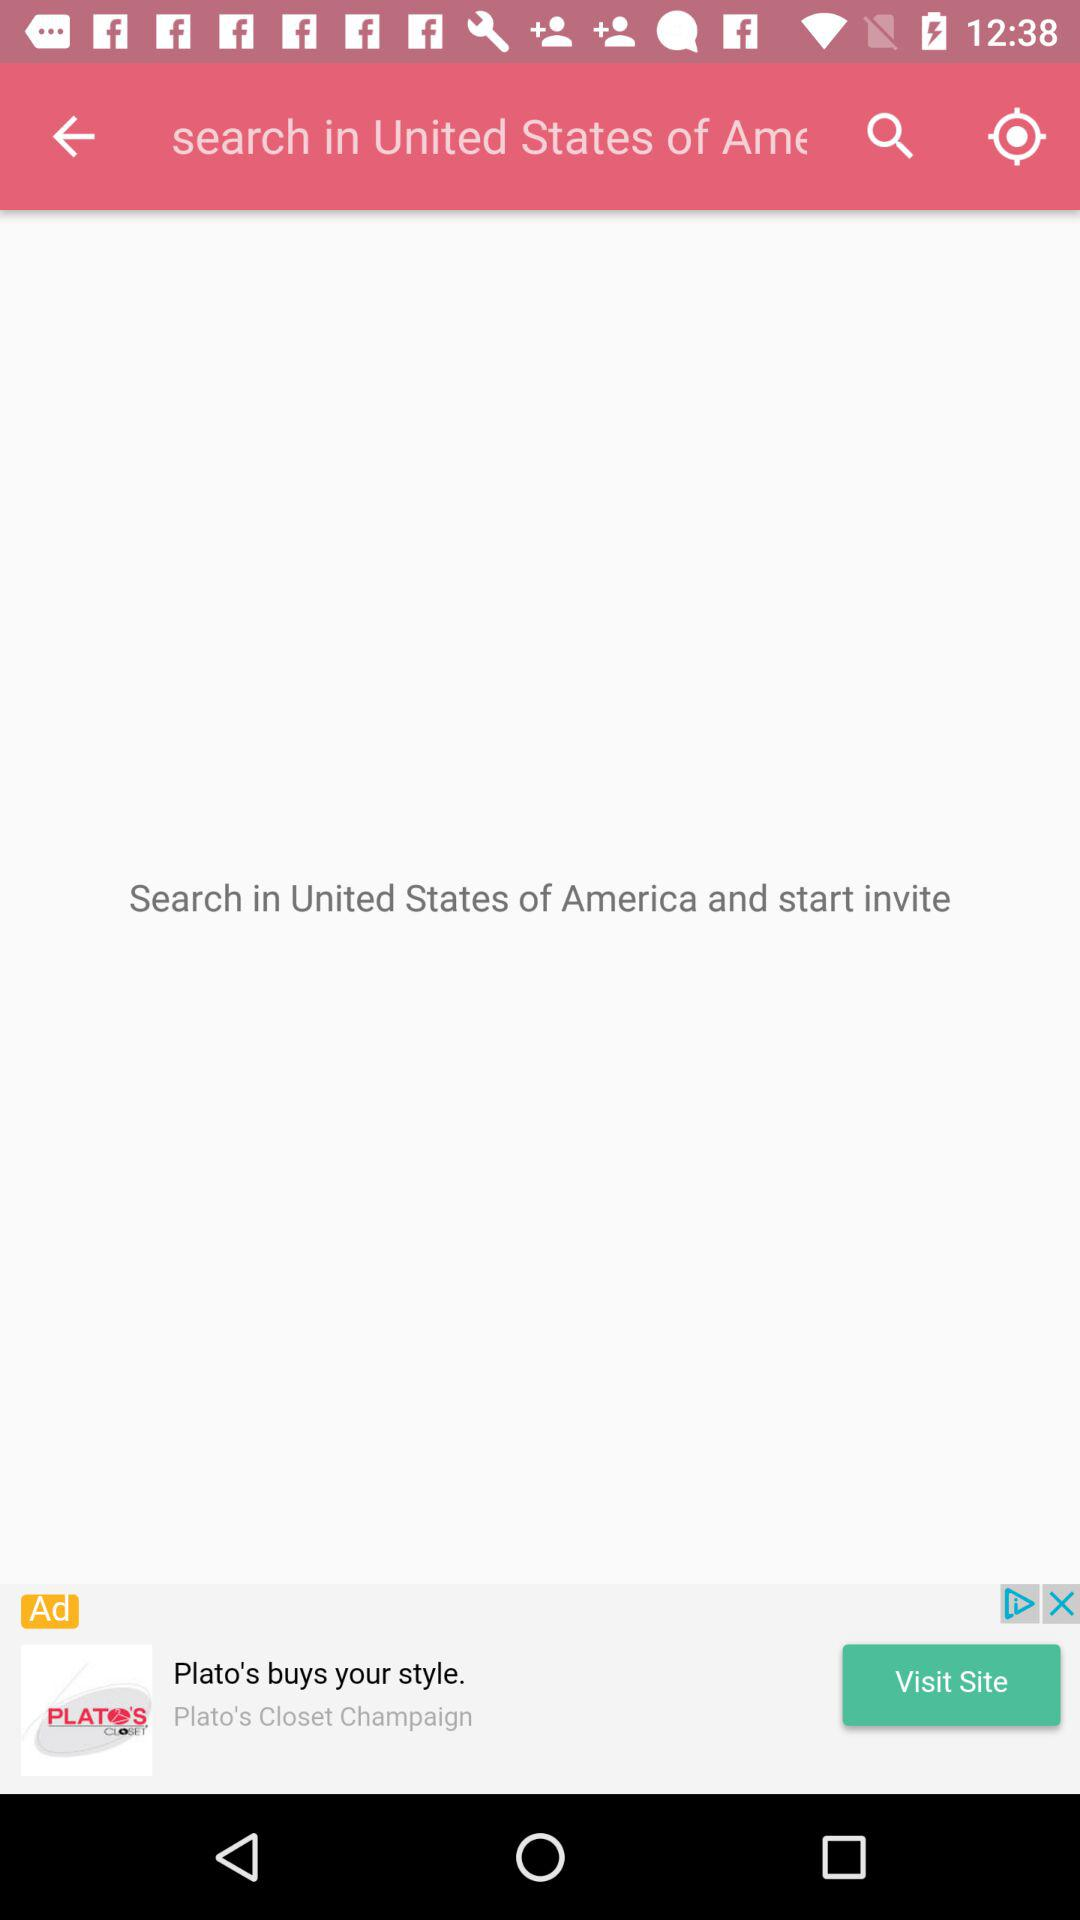In which country can I search and start inviting? You can search in the United States of America and start inviting. 